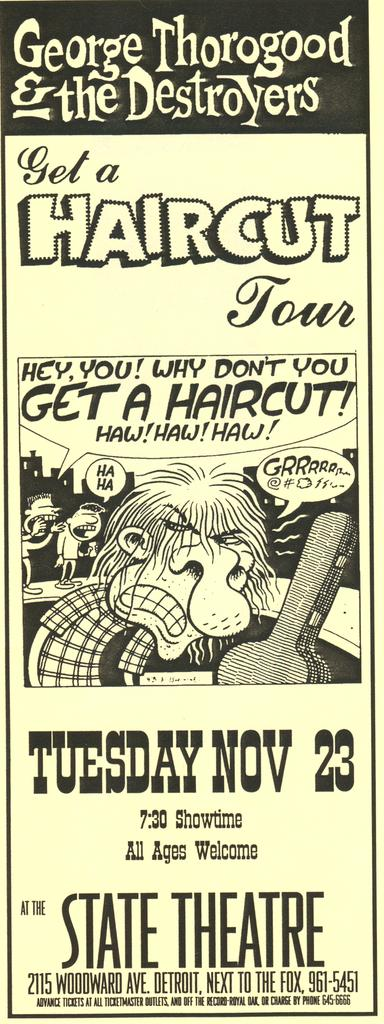<image>
Provide a brief description of the given image. Cartoon ad for "George Thorogood & the Destroyers" that is on Nov 23. 